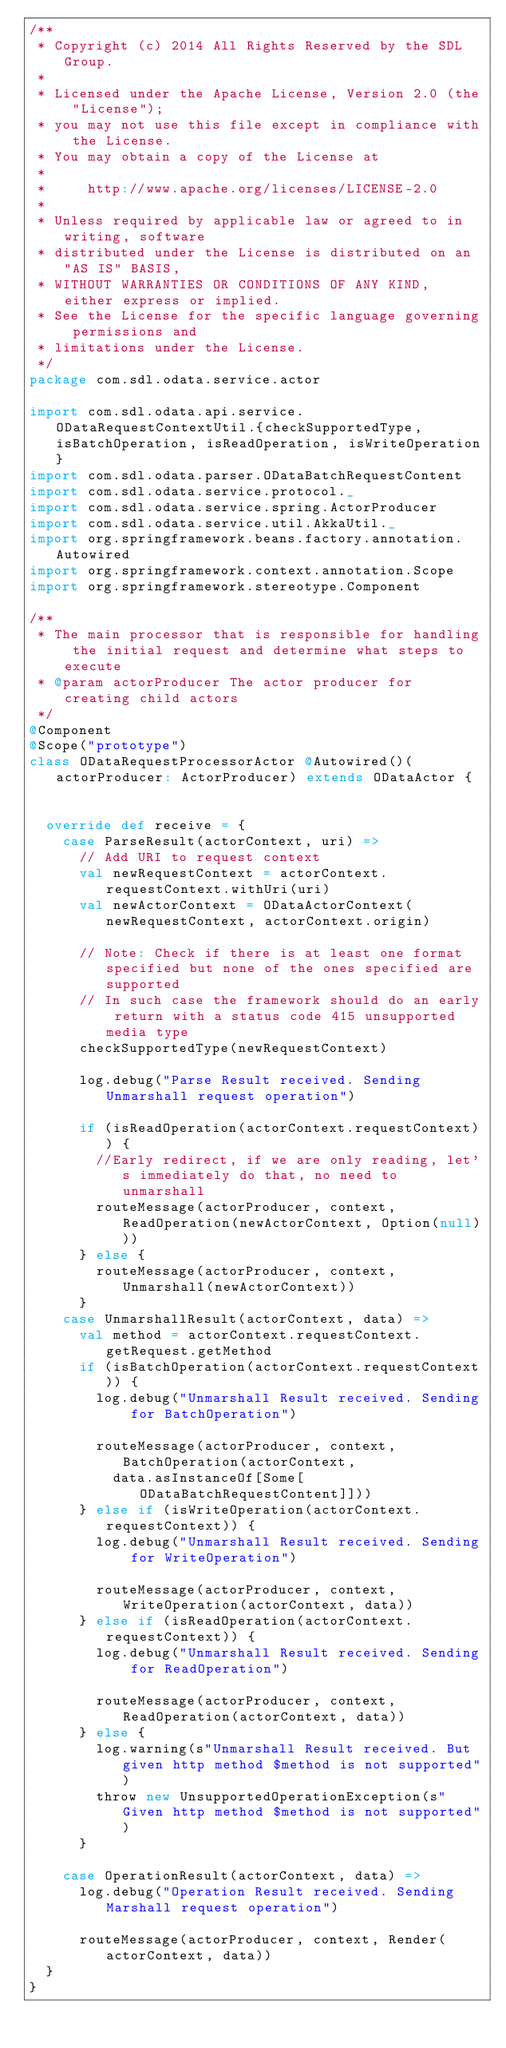<code> <loc_0><loc_0><loc_500><loc_500><_Scala_>/**
 * Copyright (c) 2014 All Rights Reserved by the SDL Group.
 *
 * Licensed under the Apache License, Version 2.0 (the "License");
 * you may not use this file except in compliance with the License.
 * You may obtain a copy of the License at
 *
 *     http://www.apache.org/licenses/LICENSE-2.0
 *
 * Unless required by applicable law or agreed to in writing, software
 * distributed under the License is distributed on an "AS IS" BASIS,
 * WITHOUT WARRANTIES OR CONDITIONS OF ANY KIND, either express or implied.
 * See the License for the specific language governing permissions and
 * limitations under the License.
 */
package com.sdl.odata.service.actor

import com.sdl.odata.api.service.ODataRequestContextUtil.{checkSupportedType, isBatchOperation, isReadOperation, isWriteOperation}
import com.sdl.odata.parser.ODataBatchRequestContent
import com.sdl.odata.service.protocol._
import com.sdl.odata.service.spring.ActorProducer
import com.sdl.odata.service.util.AkkaUtil._
import org.springframework.beans.factory.annotation.Autowired
import org.springframework.context.annotation.Scope
import org.springframework.stereotype.Component

/**
 * The main processor that is responsible for handling the initial request and determine what steps to execute
 * @param actorProducer The actor producer for creating child actors
 */
@Component
@Scope("prototype")
class ODataRequestProcessorActor @Autowired()(actorProducer: ActorProducer) extends ODataActor {


  override def receive = {
    case ParseResult(actorContext, uri) =>
      // Add URI to request context
      val newRequestContext = actorContext.requestContext.withUri(uri)
      val newActorContext = ODataActorContext(newRequestContext, actorContext.origin)

      // Note: Check if there is at least one format specified but none of the ones specified are supported
      // In such case the framework should do an early return with a status code 415 unsupported media type
      checkSupportedType(newRequestContext)

      log.debug("Parse Result received. Sending Unmarshall request operation")

      if (isReadOperation(actorContext.requestContext)) {
        //Early redirect, if we are only reading, let's immediately do that, no need to unmarshall
        routeMessage(actorProducer, context, ReadOperation(newActorContext, Option(null)))
      } else {
        routeMessage(actorProducer, context, Unmarshall(newActorContext))
      }
    case UnmarshallResult(actorContext, data) =>
      val method = actorContext.requestContext.getRequest.getMethod
      if (isBatchOperation(actorContext.requestContext)) {
        log.debug("Unmarshall Result received. Sending for BatchOperation")

        routeMessage(actorProducer, context, BatchOperation(actorContext,
          data.asInstanceOf[Some[ODataBatchRequestContent]]))
      } else if (isWriteOperation(actorContext.requestContext)) {
        log.debug("Unmarshall Result received. Sending for WriteOperation")

        routeMessage(actorProducer, context, WriteOperation(actorContext, data))
      } else if (isReadOperation(actorContext.requestContext)) {
        log.debug("Unmarshall Result received. Sending for ReadOperation")

        routeMessage(actorProducer, context, ReadOperation(actorContext, data))
      } else {
        log.warning(s"Unmarshall Result received. But given http method $method is not supported")
        throw new UnsupportedOperationException(s"Given http method $method is not supported")
      }

    case OperationResult(actorContext, data) =>
      log.debug("Operation Result received. Sending Marshall request operation")

      routeMessage(actorProducer, context, Render(actorContext, data))
  }
}
</code> 